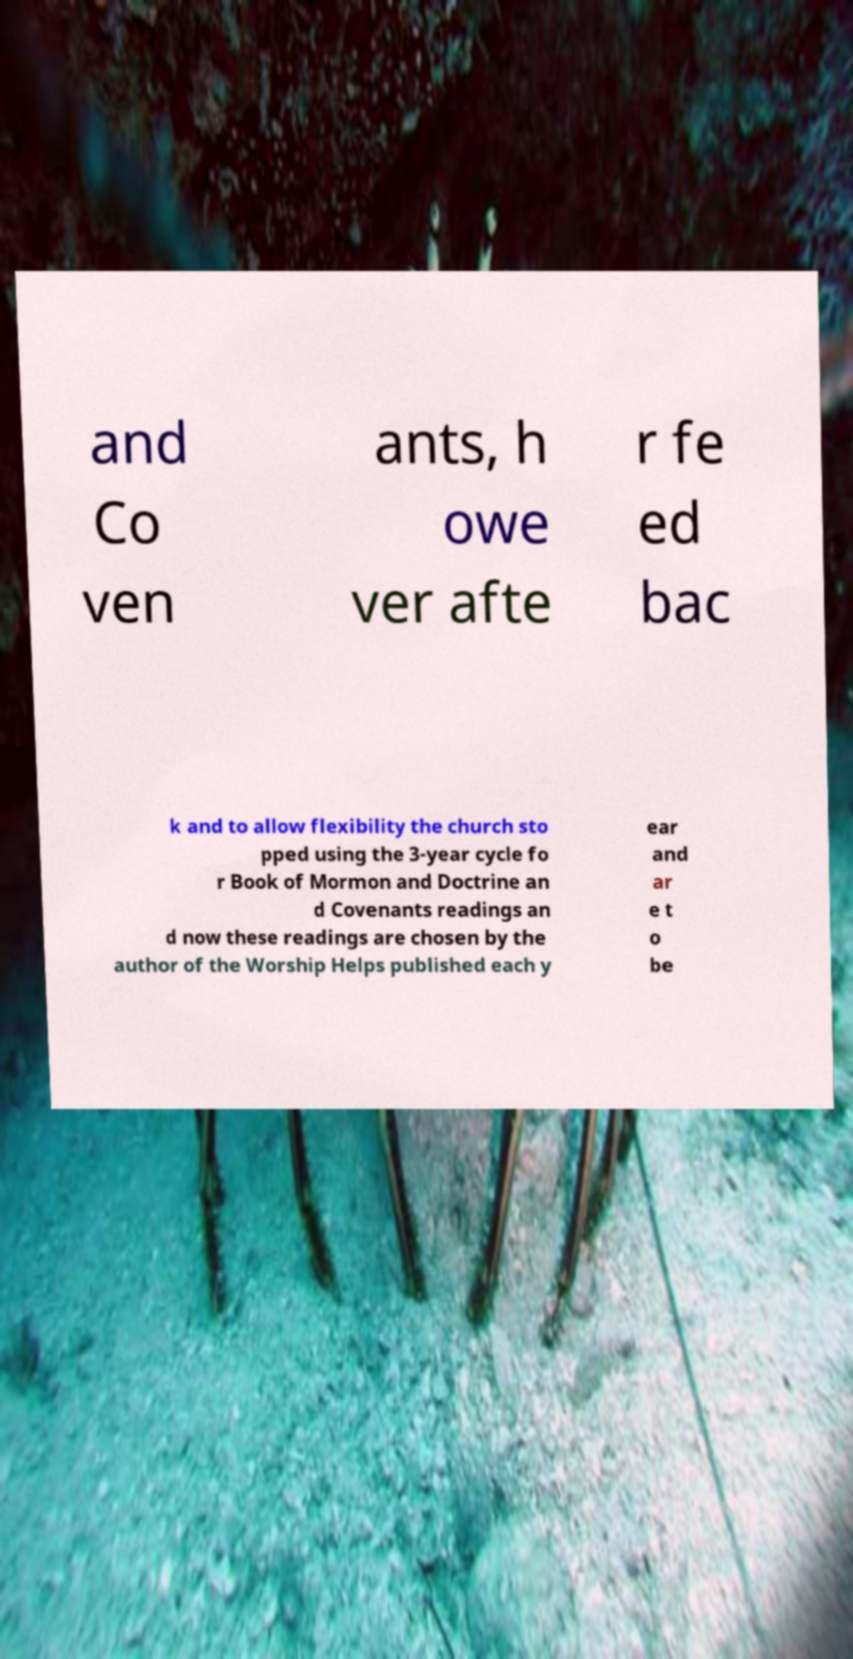Can you accurately transcribe the text from the provided image for me? and Co ven ants, h owe ver afte r fe ed bac k and to allow flexibility the church sto pped using the 3-year cycle fo r Book of Mormon and Doctrine an d Covenants readings an d now these readings are chosen by the author of the Worship Helps published each y ear and ar e t o be 